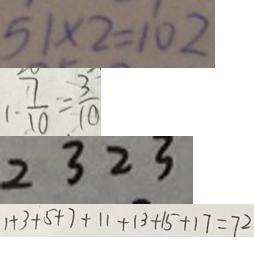Convert formula to latex. <formula><loc_0><loc_0><loc_500><loc_500>5 1 \times 2 = 1 0 2 
 1 - \frac { 7 } { 1 0 } = \frac { 3 } { 1 0 } 
 2 3 2 3 
 1 + 3 + 5 + 7 + 1 1 + 1 3 + 1 5 + 1 7 = 7 2</formula> 